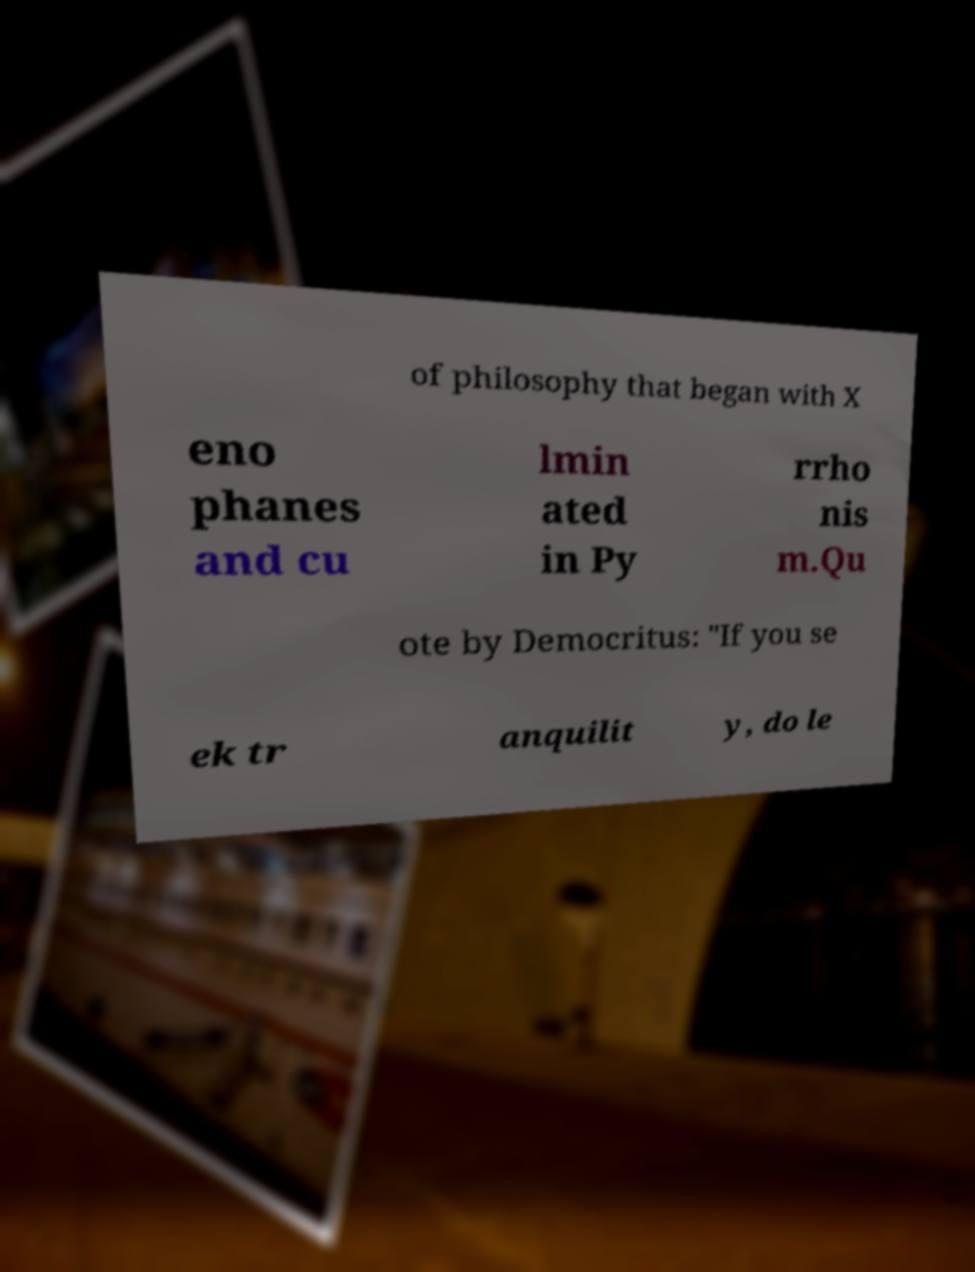Can you read and provide the text displayed in the image?This photo seems to have some interesting text. Can you extract and type it out for me? of philosophy that began with X eno phanes and cu lmin ated in Py rrho nis m.Qu ote by Democritus: "If you se ek tr anquilit y, do le 